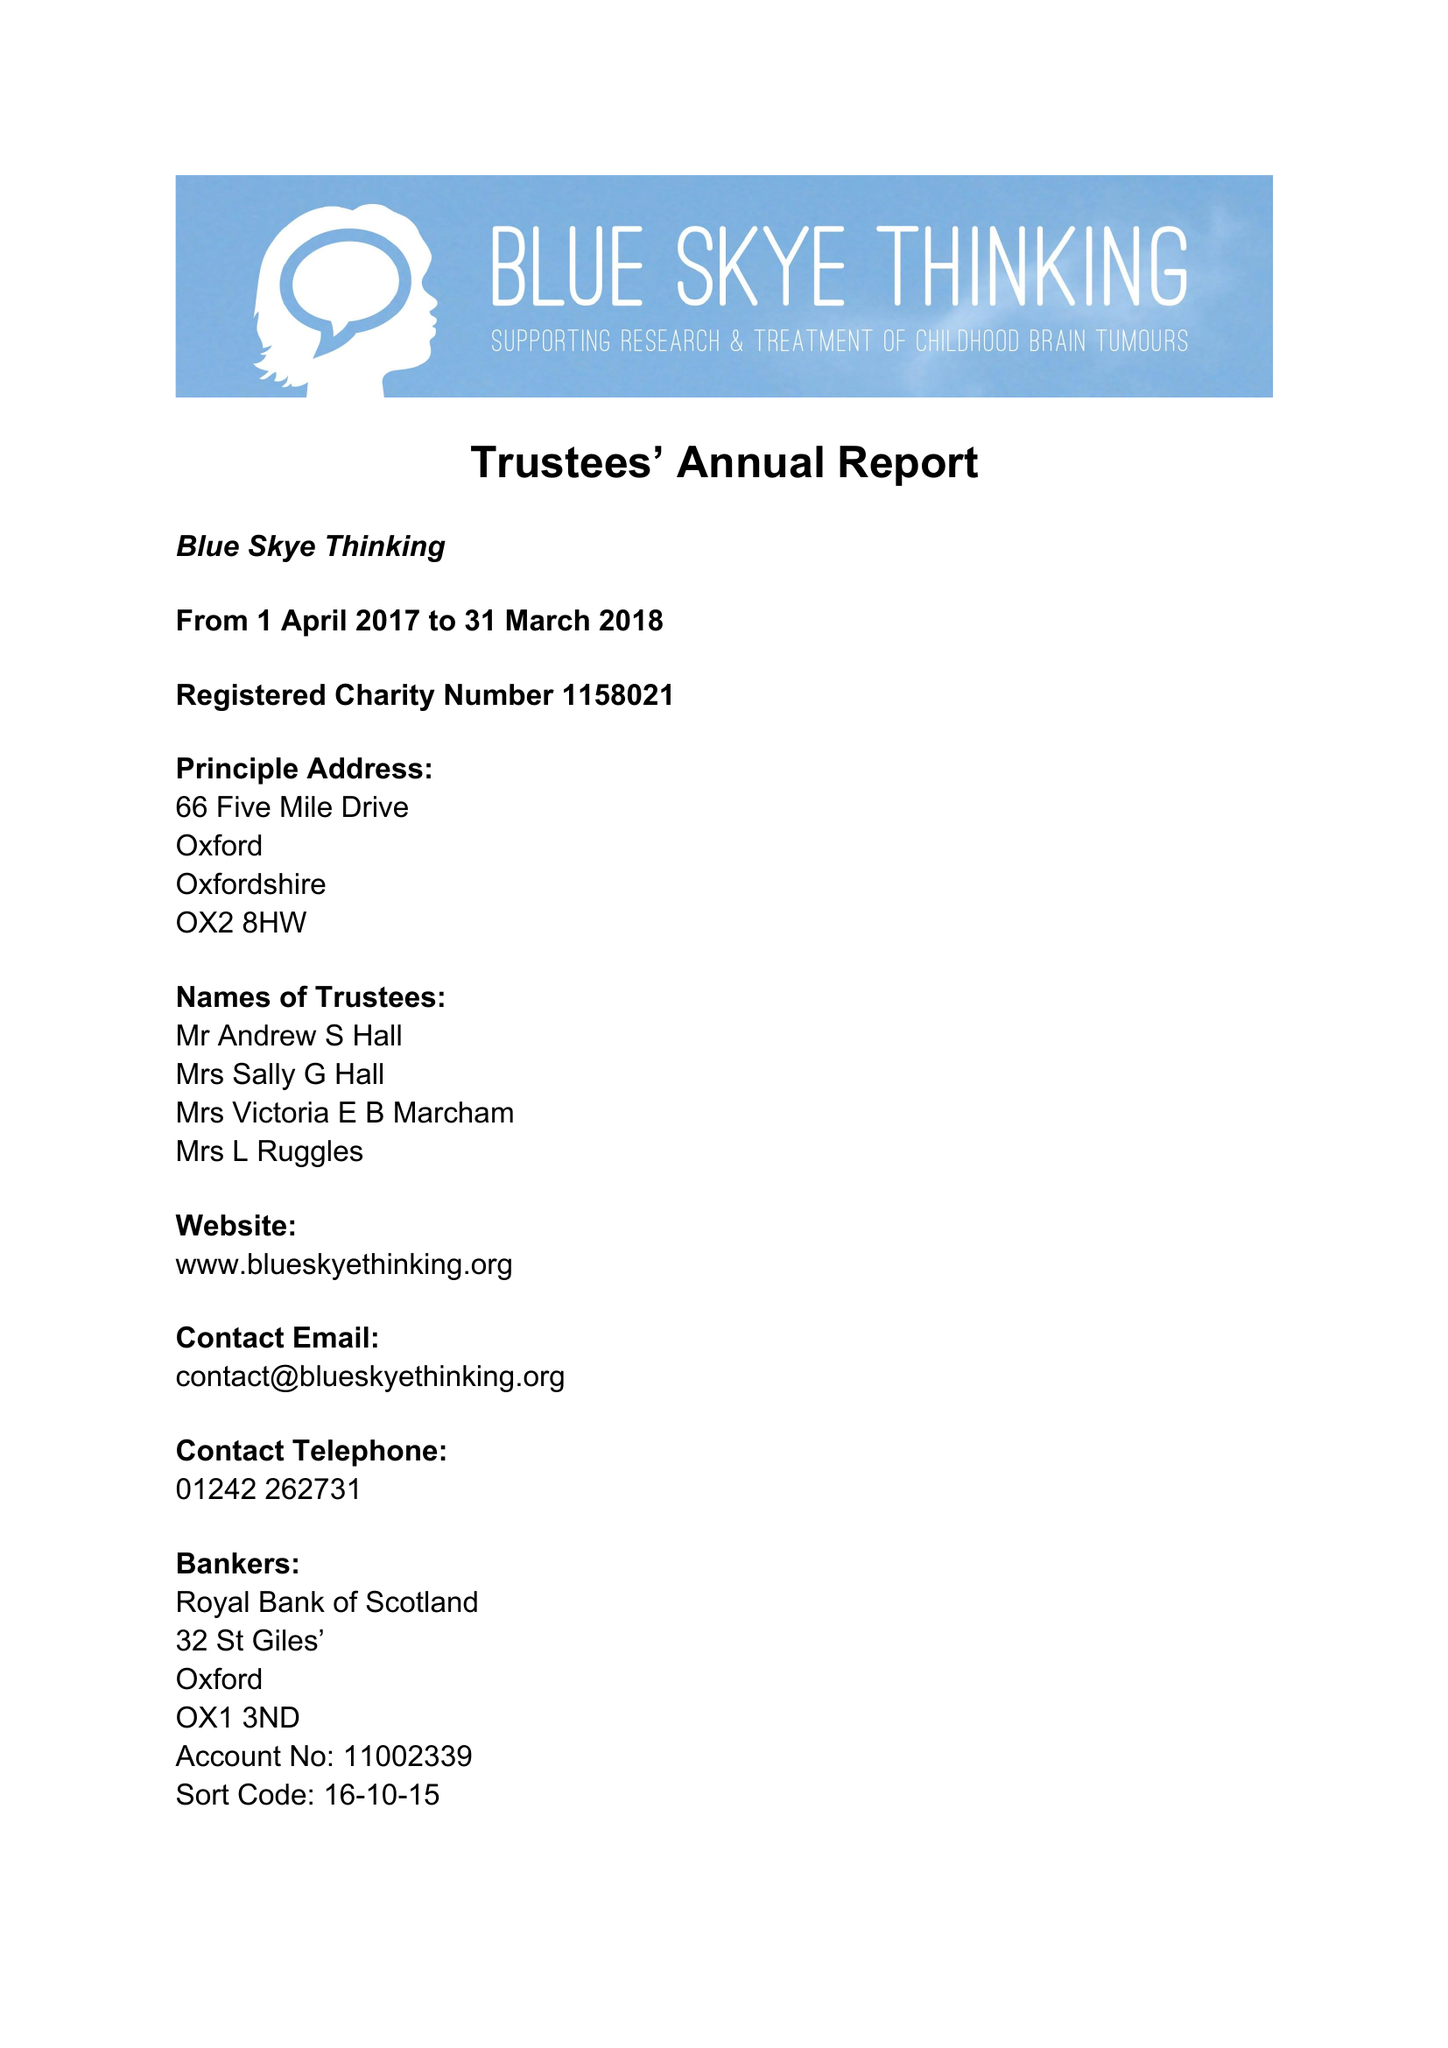What is the value for the report_date?
Answer the question using a single word or phrase. 2018-03-31 